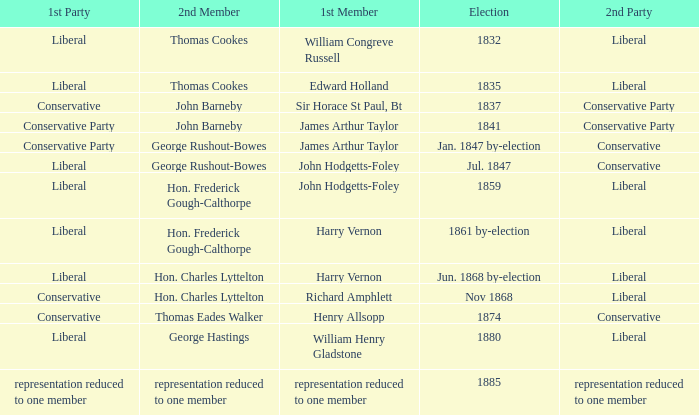What was the 2nd Party when its 2nd Member was George Rushout-Bowes, and the 1st Party was Liberal? Conservative. 